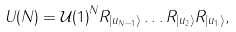Convert formula to latex. <formula><loc_0><loc_0><loc_500><loc_500>U ( N ) = { \mathcal { U } ( 1 ) } ^ { N } R _ { | u _ { N - 1 } \rangle } \dots R _ { | u _ { 2 } \rangle } R _ { | u _ { 1 } \rangle } ,</formula> 